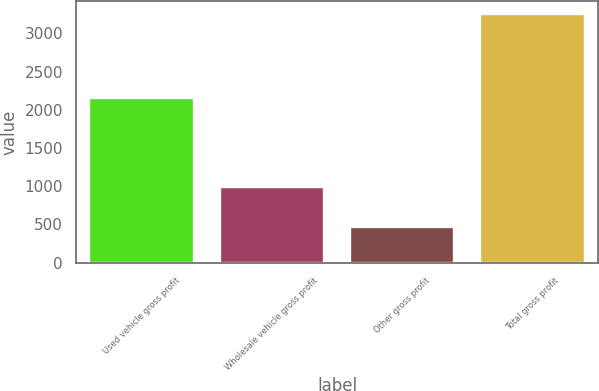<chart> <loc_0><loc_0><loc_500><loc_500><bar_chart><fcel>Used vehicle gross profit<fcel>Wholesale vehicle gross profit<fcel>Other gross profit<fcel>Total gross profit<nl><fcel>2159<fcel>984<fcel>471<fcel>3256<nl></chart> 